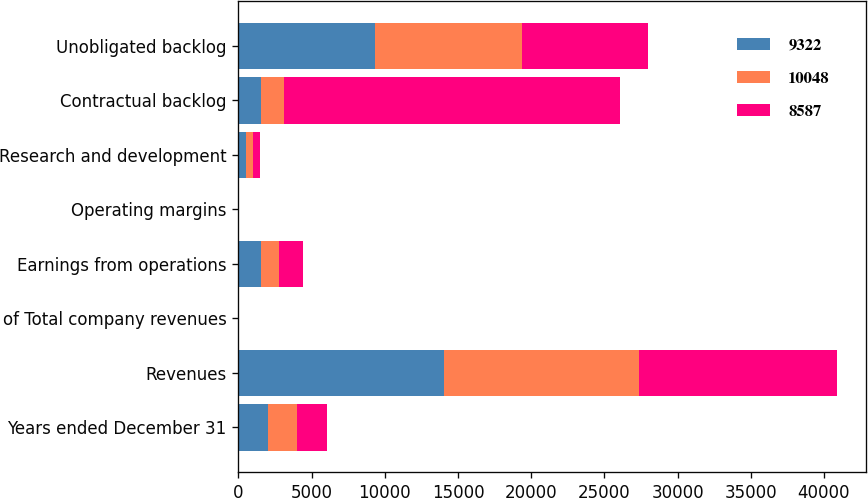Convert chart. <chart><loc_0><loc_0><loc_500><loc_500><stacked_bar_chart><ecel><fcel>Years ended December 31<fcel>Revenues<fcel>of Total company revenues<fcel>Earnings from operations<fcel>Operating margins<fcel>Research and development<fcel>Contractual backlog<fcel>Unobligated backlog<nl><fcel>9322<fcel>2009<fcel>14057<fcel>20<fcel>1513<fcel>10.8<fcel>541<fcel>1560<fcel>9322<nl><fcel>10048<fcel>2008<fcel>13311<fcel>22<fcel>1277<fcel>9.6<fcel>479<fcel>1560<fcel>10048<nl><fcel>8587<fcel>2007<fcel>13499<fcel>20<fcel>1607<fcel>11.9<fcel>445<fcel>22974<fcel>8587<nl></chart> 